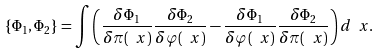Convert formula to latex. <formula><loc_0><loc_0><loc_500><loc_500>\{ \Phi _ { 1 } , \Phi _ { 2 } \} = \int \left ( \frac { \delta \Phi _ { 1 } } { \delta \pi ( \ x ) } \frac { \delta \Phi _ { 2 } } { \delta \varphi ( \ x ) } - \frac { \delta \Phi _ { 1 } } { \delta \varphi ( \ x ) } \frac { \delta \Phi _ { 2 } } { \delta \pi ( \ x ) } \right ) d \ x .</formula> 